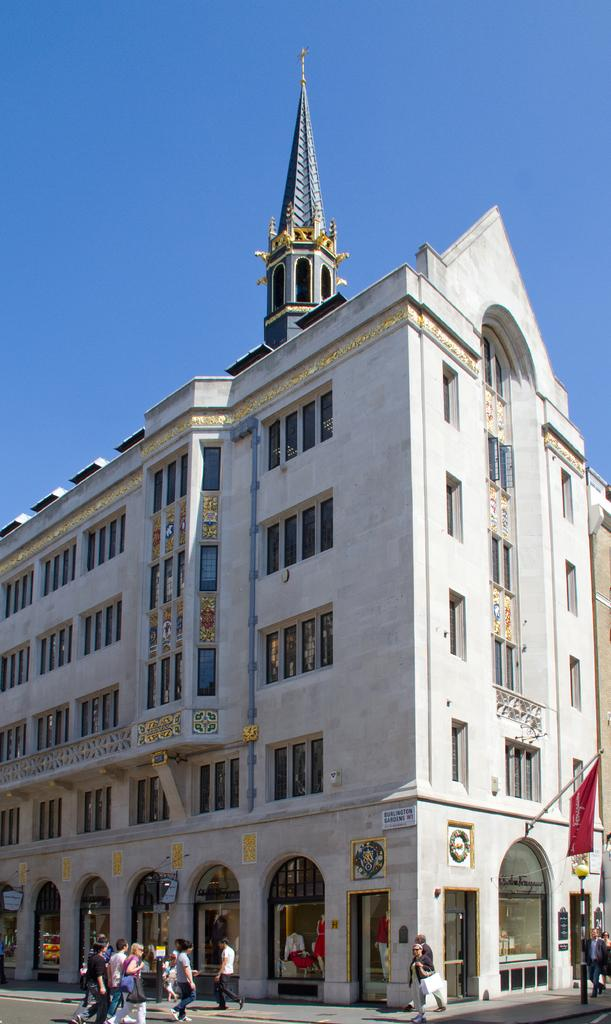What structure is the main subject of the image? There is a building in the image. What is located in front of the building? There is a footpath in front of the building. What are the people on the footpath doing? People are walking on the footpath. What can be seen in the background of the image? There is a blue sky visible in the background. How many giants can be seen walking on the footpath in the image? There are no giants present in the image; only people are walking on the footpath. Are there any women visible in the image? The provided facts do not specify the gender of the people walking on the footpath, so it cannot be determined if there are any women present. 